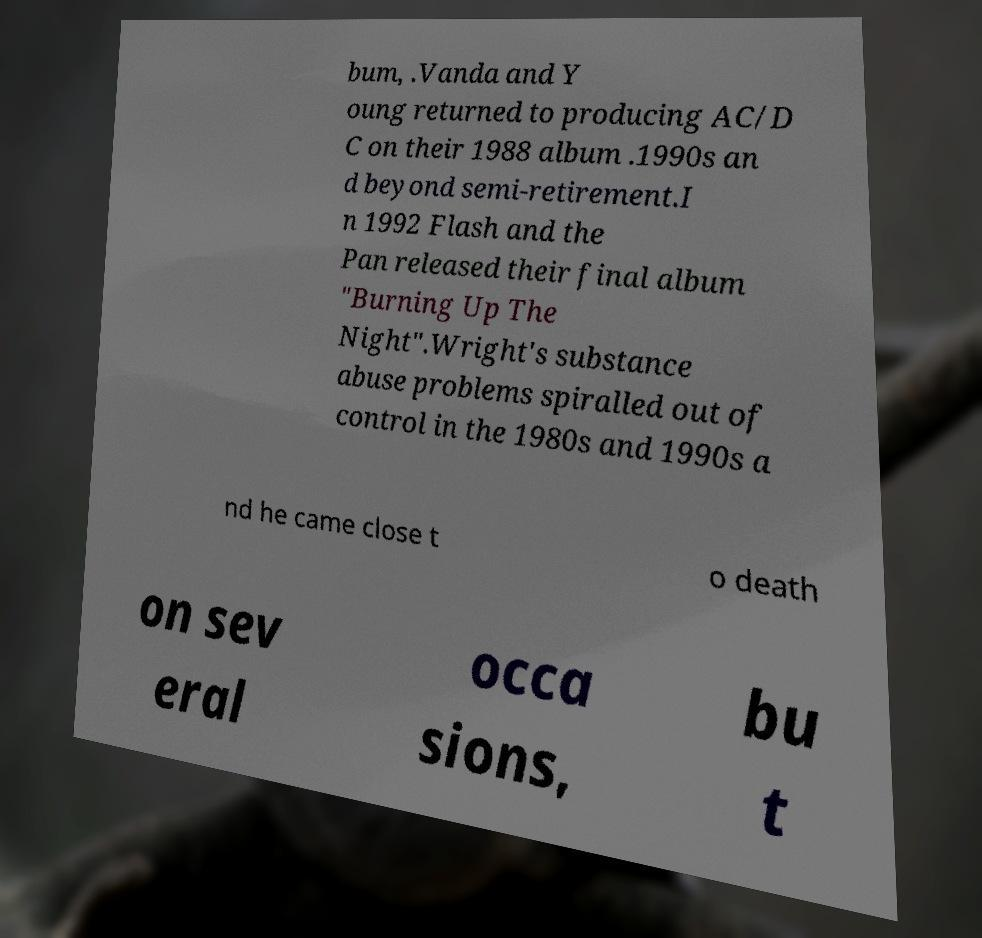Please read and relay the text visible in this image. What does it say? bum, .Vanda and Y oung returned to producing AC/D C on their 1988 album .1990s an d beyond semi-retirement.I n 1992 Flash and the Pan released their final album "Burning Up The Night".Wright's substance abuse problems spiralled out of control in the 1980s and 1990s a nd he came close t o death on sev eral occa sions, bu t 